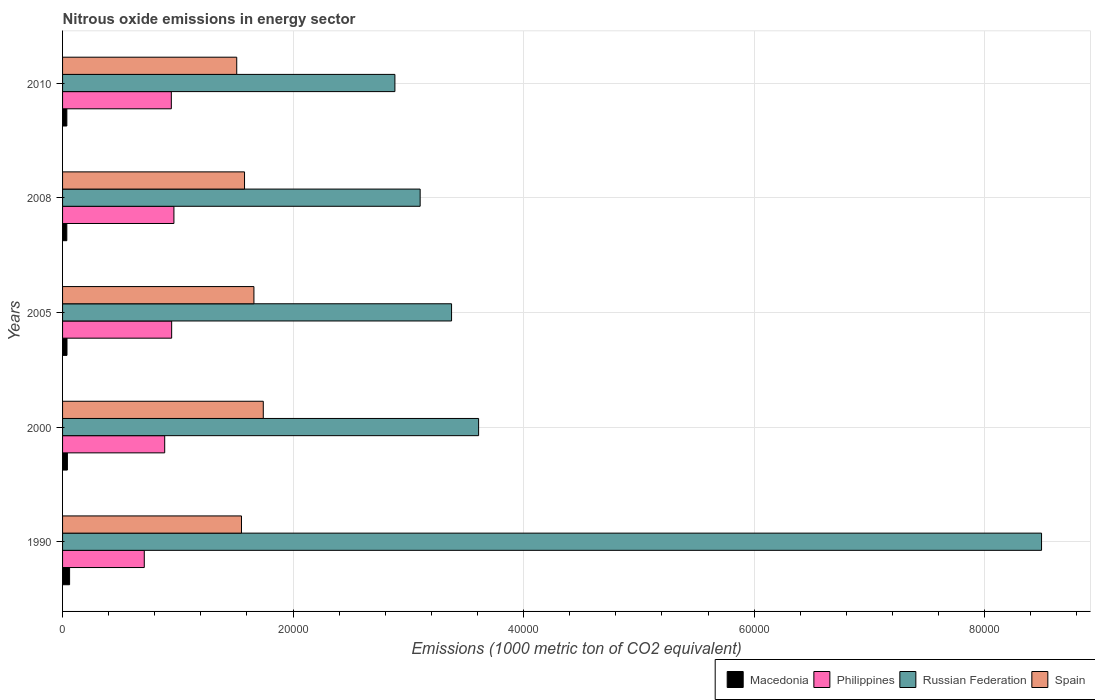Are the number of bars per tick equal to the number of legend labels?
Offer a terse response. Yes. Are the number of bars on each tick of the Y-axis equal?
Your answer should be compact. Yes. How many bars are there on the 4th tick from the bottom?
Your answer should be compact. 4. In how many cases, is the number of bars for a given year not equal to the number of legend labels?
Provide a short and direct response. 0. What is the amount of nitrous oxide emitted in Spain in 2000?
Ensure brevity in your answer.  1.74e+04. Across all years, what is the maximum amount of nitrous oxide emitted in Macedonia?
Give a very brief answer. 610.4. Across all years, what is the minimum amount of nitrous oxide emitted in Philippines?
Offer a terse response. 7090.2. What is the total amount of nitrous oxide emitted in Macedonia in the graph?
Provide a succinct answer. 2151.1. What is the difference between the amount of nitrous oxide emitted in Philippines in 2000 and that in 2008?
Provide a succinct answer. -799.7. What is the difference between the amount of nitrous oxide emitted in Russian Federation in 2000 and the amount of nitrous oxide emitted in Spain in 2008?
Ensure brevity in your answer.  2.03e+04. What is the average amount of nitrous oxide emitted in Philippines per year?
Give a very brief answer. 8902.72. In the year 1990, what is the difference between the amount of nitrous oxide emitted in Russian Federation and amount of nitrous oxide emitted in Spain?
Provide a short and direct response. 6.94e+04. In how many years, is the amount of nitrous oxide emitted in Macedonia greater than 20000 1000 metric ton?
Make the answer very short. 0. What is the ratio of the amount of nitrous oxide emitted in Spain in 2008 to that in 2010?
Ensure brevity in your answer.  1.04. Is the difference between the amount of nitrous oxide emitted in Russian Federation in 2005 and 2010 greater than the difference between the amount of nitrous oxide emitted in Spain in 2005 and 2010?
Keep it short and to the point. Yes. What is the difference between the highest and the second highest amount of nitrous oxide emitted in Philippines?
Your response must be concise. 195.7. What is the difference between the highest and the lowest amount of nitrous oxide emitted in Russian Federation?
Ensure brevity in your answer.  5.61e+04. Is the sum of the amount of nitrous oxide emitted in Macedonia in 2005 and 2008 greater than the maximum amount of nitrous oxide emitted in Philippines across all years?
Your response must be concise. No. What does the 1st bar from the top in 1990 represents?
Provide a succinct answer. Spain. What does the 4th bar from the bottom in 2008 represents?
Your answer should be compact. Spain. Is it the case that in every year, the sum of the amount of nitrous oxide emitted in Macedonia and amount of nitrous oxide emitted in Russian Federation is greater than the amount of nitrous oxide emitted in Spain?
Provide a succinct answer. Yes. How many years are there in the graph?
Your answer should be very brief. 5. What is the difference between two consecutive major ticks on the X-axis?
Provide a succinct answer. 2.00e+04. Are the values on the major ticks of X-axis written in scientific E-notation?
Give a very brief answer. No. Does the graph contain any zero values?
Provide a succinct answer. No. Does the graph contain grids?
Your response must be concise. Yes. How are the legend labels stacked?
Your response must be concise. Horizontal. What is the title of the graph?
Make the answer very short. Nitrous oxide emissions in energy sector. What is the label or title of the X-axis?
Your answer should be compact. Emissions (1000 metric ton of CO2 equivalent). What is the label or title of the Y-axis?
Provide a short and direct response. Years. What is the Emissions (1000 metric ton of CO2 equivalent) of Macedonia in 1990?
Keep it short and to the point. 610.4. What is the Emissions (1000 metric ton of CO2 equivalent) of Philippines in 1990?
Give a very brief answer. 7090.2. What is the Emissions (1000 metric ton of CO2 equivalent) of Russian Federation in 1990?
Provide a short and direct response. 8.49e+04. What is the Emissions (1000 metric ton of CO2 equivalent) of Spain in 1990?
Keep it short and to the point. 1.55e+04. What is the Emissions (1000 metric ton of CO2 equivalent) of Macedonia in 2000?
Give a very brief answer. 418.3. What is the Emissions (1000 metric ton of CO2 equivalent) in Philippines in 2000?
Your response must be concise. 8861.1. What is the Emissions (1000 metric ton of CO2 equivalent) of Russian Federation in 2000?
Your answer should be compact. 3.61e+04. What is the Emissions (1000 metric ton of CO2 equivalent) in Spain in 2000?
Provide a succinct answer. 1.74e+04. What is the Emissions (1000 metric ton of CO2 equivalent) of Macedonia in 2005?
Provide a short and direct response. 382.8. What is the Emissions (1000 metric ton of CO2 equivalent) in Philippines in 2005?
Ensure brevity in your answer.  9465.1. What is the Emissions (1000 metric ton of CO2 equivalent) in Russian Federation in 2005?
Your response must be concise. 3.37e+04. What is the Emissions (1000 metric ton of CO2 equivalent) of Spain in 2005?
Offer a very short reply. 1.66e+04. What is the Emissions (1000 metric ton of CO2 equivalent) of Macedonia in 2008?
Ensure brevity in your answer.  368. What is the Emissions (1000 metric ton of CO2 equivalent) of Philippines in 2008?
Offer a terse response. 9660.8. What is the Emissions (1000 metric ton of CO2 equivalent) of Russian Federation in 2008?
Offer a very short reply. 3.10e+04. What is the Emissions (1000 metric ton of CO2 equivalent) of Spain in 2008?
Your answer should be very brief. 1.58e+04. What is the Emissions (1000 metric ton of CO2 equivalent) in Macedonia in 2010?
Offer a terse response. 371.6. What is the Emissions (1000 metric ton of CO2 equivalent) in Philippines in 2010?
Ensure brevity in your answer.  9436.4. What is the Emissions (1000 metric ton of CO2 equivalent) in Russian Federation in 2010?
Your answer should be compact. 2.88e+04. What is the Emissions (1000 metric ton of CO2 equivalent) in Spain in 2010?
Offer a very short reply. 1.51e+04. Across all years, what is the maximum Emissions (1000 metric ton of CO2 equivalent) of Macedonia?
Keep it short and to the point. 610.4. Across all years, what is the maximum Emissions (1000 metric ton of CO2 equivalent) in Philippines?
Provide a short and direct response. 9660.8. Across all years, what is the maximum Emissions (1000 metric ton of CO2 equivalent) in Russian Federation?
Offer a very short reply. 8.49e+04. Across all years, what is the maximum Emissions (1000 metric ton of CO2 equivalent) in Spain?
Ensure brevity in your answer.  1.74e+04. Across all years, what is the minimum Emissions (1000 metric ton of CO2 equivalent) in Macedonia?
Give a very brief answer. 368. Across all years, what is the minimum Emissions (1000 metric ton of CO2 equivalent) in Philippines?
Provide a short and direct response. 7090.2. Across all years, what is the minimum Emissions (1000 metric ton of CO2 equivalent) in Russian Federation?
Give a very brief answer. 2.88e+04. Across all years, what is the minimum Emissions (1000 metric ton of CO2 equivalent) in Spain?
Your answer should be compact. 1.51e+04. What is the total Emissions (1000 metric ton of CO2 equivalent) in Macedonia in the graph?
Provide a succinct answer. 2151.1. What is the total Emissions (1000 metric ton of CO2 equivalent) of Philippines in the graph?
Your response must be concise. 4.45e+04. What is the total Emissions (1000 metric ton of CO2 equivalent) in Russian Federation in the graph?
Give a very brief answer. 2.15e+05. What is the total Emissions (1000 metric ton of CO2 equivalent) of Spain in the graph?
Ensure brevity in your answer.  8.04e+04. What is the difference between the Emissions (1000 metric ton of CO2 equivalent) of Macedonia in 1990 and that in 2000?
Your answer should be compact. 192.1. What is the difference between the Emissions (1000 metric ton of CO2 equivalent) of Philippines in 1990 and that in 2000?
Make the answer very short. -1770.9. What is the difference between the Emissions (1000 metric ton of CO2 equivalent) in Russian Federation in 1990 and that in 2000?
Keep it short and to the point. 4.88e+04. What is the difference between the Emissions (1000 metric ton of CO2 equivalent) of Spain in 1990 and that in 2000?
Your answer should be very brief. -1890.8. What is the difference between the Emissions (1000 metric ton of CO2 equivalent) of Macedonia in 1990 and that in 2005?
Ensure brevity in your answer.  227.6. What is the difference between the Emissions (1000 metric ton of CO2 equivalent) in Philippines in 1990 and that in 2005?
Make the answer very short. -2374.9. What is the difference between the Emissions (1000 metric ton of CO2 equivalent) in Russian Federation in 1990 and that in 2005?
Offer a terse response. 5.12e+04. What is the difference between the Emissions (1000 metric ton of CO2 equivalent) in Spain in 1990 and that in 2005?
Give a very brief answer. -1078.3. What is the difference between the Emissions (1000 metric ton of CO2 equivalent) of Macedonia in 1990 and that in 2008?
Make the answer very short. 242.4. What is the difference between the Emissions (1000 metric ton of CO2 equivalent) in Philippines in 1990 and that in 2008?
Ensure brevity in your answer.  -2570.6. What is the difference between the Emissions (1000 metric ton of CO2 equivalent) in Russian Federation in 1990 and that in 2008?
Offer a terse response. 5.39e+04. What is the difference between the Emissions (1000 metric ton of CO2 equivalent) in Spain in 1990 and that in 2008?
Ensure brevity in your answer.  -264.1. What is the difference between the Emissions (1000 metric ton of CO2 equivalent) in Macedonia in 1990 and that in 2010?
Make the answer very short. 238.8. What is the difference between the Emissions (1000 metric ton of CO2 equivalent) in Philippines in 1990 and that in 2010?
Your answer should be compact. -2346.2. What is the difference between the Emissions (1000 metric ton of CO2 equivalent) in Russian Federation in 1990 and that in 2010?
Keep it short and to the point. 5.61e+04. What is the difference between the Emissions (1000 metric ton of CO2 equivalent) in Spain in 1990 and that in 2010?
Your answer should be compact. 411.7. What is the difference between the Emissions (1000 metric ton of CO2 equivalent) of Macedonia in 2000 and that in 2005?
Your answer should be very brief. 35.5. What is the difference between the Emissions (1000 metric ton of CO2 equivalent) in Philippines in 2000 and that in 2005?
Provide a short and direct response. -604. What is the difference between the Emissions (1000 metric ton of CO2 equivalent) in Russian Federation in 2000 and that in 2005?
Offer a very short reply. 2347.2. What is the difference between the Emissions (1000 metric ton of CO2 equivalent) of Spain in 2000 and that in 2005?
Provide a short and direct response. 812.5. What is the difference between the Emissions (1000 metric ton of CO2 equivalent) in Macedonia in 2000 and that in 2008?
Provide a succinct answer. 50.3. What is the difference between the Emissions (1000 metric ton of CO2 equivalent) of Philippines in 2000 and that in 2008?
Provide a succinct answer. -799.7. What is the difference between the Emissions (1000 metric ton of CO2 equivalent) of Russian Federation in 2000 and that in 2008?
Offer a terse response. 5072.4. What is the difference between the Emissions (1000 metric ton of CO2 equivalent) in Spain in 2000 and that in 2008?
Offer a very short reply. 1626.7. What is the difference between the Emissions (1000 metric ton of CO2 equivalent) in Macedonia in 2000 and that in 2010?
Offer a terse response. 46.7. What is the difference between the Emissions (1000 metric ton of CO2 equivalent) of Philippines in 2000 and that in 2010?
Offer a terse response. -575.3. What is the difference between the Emissions (1000 metric ton of CO2 equivalent) in Russian Federation in 2000 and that in 2010?
Offer a very short reply. 7261.9. What is the difference between the Emissions (1000 metric ton of CO2 equivalent) of Spain in 2000 and that in 2010?
Your answer should be compact. 2302.5. What is the difference between the Emissions (1000 metric ton of CO2 equivalent) of Philippines in 2005 and that in 2008?
Offer a terse response. -195.7. What is the difference between the Emissions (1000 metric ton of CO2 equivalent) in Russian Federation in 2005 and that in 2008?
Your answer should be compact. 2725.2. What is the difference between the Emissions (1000 metric ton of CO2 equivalent) in Spain in 2005 and that in 2008?
Keep it short and to the point. 814.2. What is the difference between the Emissions (1000 metric ton of CO2 equivalent) in Philippines in 2005 and that in 2010?
Your answer should be very brief. 28.7. What is the difference between the Emissions (1000 metric ton of CO2 equivalent) of Russian Federation in 2005 and that in 2010?
Offer a very short reply. 4914.7. What is the difference between the Emissions (1000 metric ton of CO2 equivalent) in Spain in 2005 and that in 2010?
Your answer should be compact. 1490. What is the difference between the Emissions (1000 metric ton of CO2 equivalent) of Philippines in 2008 and that in 2010?
Give a very brief answer. 224.4. What is the difference between the Emissions (1000 metric ton of CO2 equivalent) in Russian Federation in 2008 and that in 2010?
Your answer should be very brief. 2189.5. What is the difference between the Emissions (1000 metric ton of CO2 equivalent) in Spain in 2008 and that in 2010?
Provide a short and direct response. 675.8. What is the difference between the Emissions (1000 metric ton of CO2 equivalent) of Macedonia in 1990 and the Emissions (1000 metric ton of CO2 equivalent) of Philippines in 2000?
Provide a short and direct response. -8250.7. What is the difference between the Emissions (1000 metric ton of CO2 equivalent) of Macedonia in 1990 and the Emissions (1000 metric ton of CO2 equivalent) of Russian Federation in 2000?
Your answer should be very brief. -3.55e+04. What is the difference between the Emissions (1000 metric ton of CO2 equivalent) of Macedonia in 1990 and the Emissions (1000 metric ton of CO2 equivalent) of Spain in 2000?
Give a very brief answer. -1.68e+04. What is the difference between the Emissions (1000 metric ton of CO2 equivalent) of Philippines in 1990 and the Emissions (1000 metric ton of CO2 equivalent) of Russian Federation in 2000?
Offer a very short reply. -2.90e+04. What is the difference between the Emissions (1000 metric ton of CO2 equivalent) in Philippines in 1990 and the Emissions (1000 metric ton of CO2 equivalent) in Spain in 2000?
Your response must be concise. -1.03e+04. What is the difference between the Emissions (1000 metric ton of CO2 equivalent) of Russian Federation in 1990 and the Emissions (1000 metric ton of CO2 equivalent) of Spain in 2000?
Your answer should be very brief. 6.75e+04. What is the difference between the Emissions (1000 metric ton of CO2 equivalent) of Macedonia in 1990 and the Emissions (1000 metric ton of CO2 equivalent) of Philippines in 2005?
Keep it short and to the point. -8854.7. What is the difference between the Emissions (1000 metric ton of CO2 equivalent) in Macedonia in 1990 and the Emissions (1000 metric ton of CO2 equivalent) in Russian Federation in 2005?
Give a very brief answer. -3.31e+04. What is the difference between the Emissions (1000 metric ton of CO2 equivalent) of Macedonia in 1990 and the Emissions (1000 metric ton of CO2 equivalent) of Spain in 2005?
Your answer should be compact. -1.60e+04. What is the difference between the Emissions (1000 metric ton of CO2 equivalent) of Philippines in 1990 and the Emissions (1000 metric ton of CO2 equivalent) of Russian Federation in 2005?
Your response must be concise. -2.67e+04. What is the difference between the Emissions (1000 metric ton of CO2 equivalent) in Philippines in 1990 and the Emissions (1000 metric ton of CO2 equivalent) in Spain in 2005?
Provide a short and direct response. -9511.1. What is the difference between the Emissions (1000 metric ton of CO2 equivalent) in Russian Federation in 1990 and the Emissions (1000 metric ton of CO2 equivalent) in Spain in 2005?
Your answer should be compact. 6.83e+04. What is the difference between the Emissions (1000 metric ton of CO2 equivalent) in Macedonia in 1990 and the Emissions (1000 metric ton of CO2 equivalent) in Philippines in 2008?
Provide a short and direct response. -9050.4. What is the difference between the Emissions (1000 metric ton of CO2 equivalent) in Macedonia in 1990 and the Emissions (1000 metric ton of CO2 equivalent) in Russian Federation in 2008?
Give a very brief answer. -3.04e+04. What is the difference between the Emissions (1000 metric ton of CO2 equivalent) in Macedonia in 1990 and the Emissions (1000 metric ton of CO2 equivalent) in Spain in 2008?
Your answer should be compact. -1.52e+04. What is the difference between the Emissions (1000 metric ton of CO2 equivalent) in Philippines in 1990 and the Emissions (1000 metric ton of CO2 equivalent) in Russian Federation in 2008?
Provide a short and direct response. -2.39e+04. What is the difference between the Emissions (1000 metric ton of CO2 equivalent) of Philippines in 1990 and the Emissions (1000 metric ton of CO2 equivalent) of Spain in 2008?
Your answer should be compact. -8696.9. What is the difference between the Emissions (1000 metric ton of CO2 equivalent) in Russian Federation in 1990 and the Emissions (1000 metric ton of CO2 equivalent) in Spain in 2008?
Offer a very short reply. 6.91e+04. What is the difference between the Emissions (1000 metric ton of CO2 equivalent) in Macedonia in 1990 and the Emissions (1000 metric ton of CO2 equivalent) in Philippines in 2010?
Give a very brief answer. -8826. What is the difference between the Emissions (1000 metric ton of CO2 equivalent) in Macedonia in 1990 and the Emissions (1000 metric ton of CO2 equivalent) in Russian Federation in 2010?
Provide a succinct answer. -2.82e+04. What is the difference between the Emissions (1000 metric ton of CO2 equivalent) of Macedonia in 1990 and the Emissions (1000 metric ton of CO2 equivalent) of Spain in 2010?
Offer a terse response. -1.45e+04. What is the difference between the Emissions (1000 metric ton of CO2 equivalent) of Philippines in 1990 and the Emissions (1000 metric ton of CO2 equivalent) of Russian Federation in 2010?
Offer a very short reply. -2.17e+04. What is the difference between the Emissions (1000 metric ton of CO2 equivalent) in Philippines in 1990 and the Emissions (1000 metric ton of CO2 equivalent) in Spain in 2010?
Ensure brevity in your answer.  -8021.1. What is the difference between the Emissions (1000 metric ton of CO2 equivalent) in Russian Federation in 1990 and the Emissions (1000 metric ton of CO2 equivalent) in Spain in 2010?
Provide a succinct answer. 6.98e+04. What is the difference between the Emissions (1000 metric ton of CO2 equivalent) in Macedonia in 2000 and the Emissions (1000 metric ton of CO2 equivalent) in Philippines in 2005?
Offer a very short reply. -9046.8. What is the difference between the Emissions (1000 metric ton of CO2 equivalent) in Macedonia in 2000 and the Emissions (1000 metric ton of CO2 equivalent) in Russian Federation in 2005?
Provide a short and direct response. -3.33e+04. What is the difference between the Emissions (1000 metric ton of CO2 equivalent) of Macedonia in 2000 and the Emissions (1000 metric ton of CO2 equivalent) of Spain in 2005?
Your response must be concise. -1.62e+04. What is the difference between the Emissions (1000 metric ton of CO2 equivalent) of Philippines in 2000 and the Emissions (1000 metric ton of CO2 equivalent) of Russian Federation in 2005?
Your answer should be very brief. -2.49e+04. What is the difference between the Emissions (1000 metric ton of CO2 equivalent) of Philippines in 2000 and the Emissions (1000 metric ton of CO2 equivalent) of Spain in 2005?
Offer a terse response. -7740.2. What is the difference between the Emissions (1000 metric ton of CO2 equivalent) in Russian Federation in 2000 and the Emissions (1000 metric ton of CO2 equivalent) in Spain in 2005?
Your answer should be very brief. 1.95e+04. What is the difference between the Emissions (1000 metric ton of CO2 equivalent) of Macedonia in 2000 and the Emissions (1000 metric ton of CO2 equivalent) of Philippines in 2008?
Your answer should be very brief. -9242.5. What is the difference between the Emissions (1000 metric ton of CO2 equivalent) in Macedonia in 2000 and the Emissions (1000 metric ton of CO2 equivalent) in Russian Federation in 2008?
Your response must be concise. -3.06e+04. What is the difference between the Emissions (1000 metric ton of CO2 equivalent) of Macedonia in 2000 and the Emissions (1000 metric ton of CO2 equivalent) of Spain in 2008?
Your response must be concise. -1.54e+04. What is the difference between the Emissions (1000 metric ton of CO2 equivalent) of Philippines in 2000 and the Emissions (1000 metric ton of CO2 equivalent) of Russian Federation in 2008?
Keep it short and to the point. -2.22e+04. What is the difference between the Emissions (1000 metric ton of CO2 equivalent) of Philippines in 2000 and the Emissions (1000 metric ton of CO2 equivalent) of Spain in 2008?
Ensure brevity in your answer.  -6926. What is the difference between the Emissions (1000 metric ton of CO2 equivalent) in Russian Federation in 2000 and the Emissions (1000 metric ton of CO2 equivalent) in Spain in 2008?
Offer a terse response. 2.03e+04. What is the difference between the Emissions (1000 metric ton of CO2 equivalent) of Macedonia in 2000 and the Emissions (1000 metric ton of CO2 equivalent) of Philippines in 2010?
Give a very brief answer. -9018.1. What is the difference between the Emissions (1000 metric ton of CO2 equivalent) in Macedonia in 2000 and the Emissions (1000 metric ton of CO2 equivalent) in Russian Federation in 2010?
Ensure brevity in your answer.  -2.84e+04. What is the difference between the Emissions (1000 metric ton of CO2 equivalent) of Macedonia in 2000 and the Emissions (1000 metric ton of CO2 equivalent) of Spain in 2010?
Give a very brief answer. -1.47e+04. What is the difference between the Emissions (1000 metric ton of CO2 equivalent) in Philippines in 2000 and the Emissions (1000 metric ton of CO2 equivalent) in Russian Federation in 2010?
Ensure brevity in your answer.  -2.00e+04. What is the difference between the Emissions (1000 metric ton of CO2 equivalent) of Philippines in 2000 and the Emissions (1000 metric ton of CO2 equivalent) of Spain in 2010?
Give a very brief answer. -6250.2. What is the difference between the Emissions (1000 metric ton of CO2 equivalent) in Russian Federation in 2000 and the Emissions (1000 metric ton of CO2 equivalent) in Spain in 2010?
Your answer should be compact. 2.10e+04. What is the difference between the Emissions (1000 metric ton of CO2 equivalent) in Macedonia in 2005 and the Emissions (1000 metric ton of CO2 equivalent) in Philippines in 2008?
Your answer should be compact. -9278. What is the difference between the Emissions (1000 metric ton of CO2 equivalent) of Macedonia in 2005 and the Emissions (1000 metric ton of CO2 equivalent) of Russian Federation in 2008?
Provide a short and direct response. -3.06e+04. What is the difference between the Emissions (1000 metric ton of CO2 equivalent) of Macedonia in 2005 and the Emissions (1000 metric ton of CO2 equivalent) of Spain in 2008?
Provide a short and direct response. -1.54e+04. What is the difference between the Emissions (1000 metric ton of CO2 equivalent) in Philippines in 2005 and the Emissions (1000 metric ton of CO2 equivalent) in Russian Federation in 2008?
Your response must be concise. -2.16e+04. What is the difference between the Emissions (1000 metric ton of CO2 equivalent) in Philippines in 2005 and the Emissions (1000 metric ton of CO2 equivalent) in Spain in 2008?
Provide a short and direct response. -6322. What is the difference between the Emissions (1000 metric ton of CO2 equivalent) of Russian Federation in 2005 and the Emissions (1000 metric ton of CO2 equivalent) of Spain in 2008?
Your response must be concise. 1.80e+04. What is the difference between the Emissions (1000 metric ton of CO2 equivalent) in Macedonia in 2005 and the Emissions (1000 metric ton of CO2 equivalent) in Philippines in 2010?
Give a very brief answer. -9053.6. What is the difference between the Emissions (1000 metric ton of CO2 equivalent) of Macedonia in 2005 and the Emissions (1000 metric ton of CO2 equivalent) of Russian Federation in 2010?
Offer a terse response. -2.85e+04. What is the difference between the Emissions (1000 metric ton of CO2 equivalent) of Macedonia in 2005 and the Emissions (1000 metric ton of CO2 equivalent) of Spain in 2010?
Keep it short and to the point. -1.47e+04. What is the difference between the Emissions (1000 metric ton of CO2 equivalent) in Philippines in 2005 and the Emissions (1000 metric ton of CO2 equivalent) in Russian Federation in 2010?
Your answer should be very brief. -1.94e+04. What is the difference between the Emissions (1000 metric ton of CO2 equivalent) of Philippines in 2005 and the Emissions (1000 metric ton of CO2 equivalent) of Spain in 2010?
Your answer should be compact. -5646.2. What is the difference between the Emissions (1000 metric ton of CO2 equivalent) of Russian Federation in 2005 and the Emissions (1000 metric ton of CO2 equivalent) of Spain in 2010?
Offer a very short reply. 1.86e+04. What is the difference between the Emissions (1000 metric ton of CO2 equivalent) of Macedonia in 2008 and the Emissions (1000 metric ton of CO2 equivalent) of Philippines in 2010?
Make the answer very short. -9068.4. What is the difference between the Emissions (1000 metric ton of CO2 equivalent) in Macedonia in 2008 and the Emissions (1000 metric ton of CO2 equivalent) in Russian Federation in 2010?
Make the answer very short. -2.85e+04. What is the difference between the Emissions (1000 metric ton of CO2 equivalent) in Macedonia in 2008 and the Emissions (1000 metric ton of CO2 equivalent) in Spain in 2010?
Offer a terse response. -1.47e+04. What is the difference between the Emissions (1000 metric ton of CO2 equivalent) in Philippines in 2008 and the Emissions (1000 metric ton of CO2 equivalent) in Russian Federation in 2010?
Keep it short and to the point. -1.92e+04. What is the difference between the Emissions (1000 metric ton of CO2 equivalent) in Philippines in 2008 and the Emissions (1000 metric ton of CO2 equivalent) in Spain in 2010?
Ensure brevity in your answer.  -5450.5. What is the difference between the Emissions (1000 metric ton of CO2 equivalent) in Russian Federation in 2008 and the Emissions (1000 metric ton of CO2 equivalent) in Spain in 2010?
Offer a very short reply. 1.59e+04. What is the average Emissions (1000 metric ton of CO2 equivalent) of Macedonia per year?
Make the answer very short. 430.22. What is the average Emissions (1000 metric ton of CO2 equivalent) in Philippines per year?
Keep it short and to the point. 8902.72. What is the average Emissions (1000 metric ton of CO2 equivalent) in Russian Federation per year?
Your answer should be compact. 4.29e+04. What is the average Emissions (1000 metric ton of CO2 equivalent) of Spain per year?
Give a very brief answer. 1.61e+04. In the year 1990, what is the difference between the Emissions (1000 metric ton of CO2 equivalent) of Macedonia and Emissions (1000 metric ton of CO2 equivalent) of Philippines?
Offer a very short reply. -6479.8. In the year 1990, what is the difference between the Emissions (1000 metric ton of CO2 equivalent) of Macedonia and Emissions (1000 metric ton of CO2 equivalent) of Russian Federation?
Offer a terse response. -8.43e+04. In the year 1990, what is the difference between the Emissions (1000 metric ton of CO2 equivalent) of Macedonia and Emissions (1000 metric ton of CO2 equivalent) of Spain?
Your answer should be very brief. -1.49e+04. In the year 1990, what is the difference between the Emissions (1000 metric ton of CO2 equivalent) in Philippines and Emissions (1000 metric ton of CO2 equivalent) in Russian Federation?
Give a very brief answer. -7.78e+04. In the year 1990, what is the difference between the Emissions (1000 metric ton of CO2 equivalent) of Philippines and Emissions (1000 metric ton of CO2 equivalent) of Spain?
Keep it short and to the point. -8432.8. In the year 1990, what is the difference between the Emissions (1000 metric ton of CO2 equivalent) in Russian Federation and Emissions (1000 metric ton of CO2 equivalent) in Spain?
Your response must be concise. 6.94e+04. In the year 2000, what is the difference between the Emissions (1000 metric ton of CO2 equivalent) of Macedonia and Emissions (1000 metric ton of CO2 equivalent) of Philippines?
Offer a very short reply. -8442.8. In the year 2000, what is the difference between the Emissions (1000 metric ton of CO2 equivalent) of Macedonia and Emissions (1000 metric ton of CO2 equivalent) of Russian Federation?
Offer a very short reply. -3.57e+04. In the year 2000, what is the difference between the Emissions (1000 metric ton of CO2 equivalent) of Macedonia and Emissions (1000 metric ton of CO2 equivalent) of Spain?
Offer a very short reply. -1.70e+04. In the year 2000, what is the difference between the Emissions (1000 metric ton of CO2 equivalent) of Philippines and Emissions (1000 metric ton of CO2 equivalent) of Russian Federation?
Your answer should be very brief. -2.72e+04. In the year 2000, what is the difference between the Emissions (1000 metric ton of CO2 equivalent) in Philippines and Emissions (1000 metric ton of CO2 equivalent) in Spain?
Ensure brevity in your answer.  -8552.7. In the year 2000, what is the difference between the Emissions (1000 metric ton of CO2 equivalent) of Russian Federation and Emissions (1000 metric ton of CO2 equivalent) of Spain?
Provide a succinct answer. 1.87e+04. In the year 2005, what is the difference between the Emissions (1000 metric ton of CO2 equivalent) of Macedonia and Emissions (1000 metric ton of CO2 equivalent) of Philippines?
Give a very brief answer. -9082.3. In the year 2005, what is the difference between the Emissions (1000 metric ton of CO2 equivalent) in Macedonia and Emissions (1000 metric ton of CO2 equivalent) in Russian Federation?
Keep it short and to the point. -3.34e+04. In the year 2005, what is the difference between the Emissions (1000 metric ton of CO2 equivalent) in Macedonia and Emissions (1000 metric ton of CO2 equivalent) in Spain?
Provide a succinct answer. -1.62e+04. In the year 2005, what is the difference between the Emissions (1000 metric ton of CO2 equivalent) of Philippines and Emissions (1000 metric ton of CO2 equivalent) of Russian Federation?
Provide a short and direct response. -2.43e+04. In the year 2005, what is the difference between the Emissions (1000 metric ton of CO2 equivalent) in Philippines and Emissions (1000 metric ton of CO2 equivalent) in Spain?
Ensure brevity in your answer.  -7136.2. In the year 2005, what is the difference between the Emissions (1000 metric ton of CO2 equivalent) in Russian Federation and Emissions (1000 metric ton of CO2 equivalent) in Spain?
Your response must be concise. 1.71e+04. In the year 2008, what is the difference between the Emissions (1000 metric ton of CO2 equivalent) in Macedonia and Emissions (1000 metric ton of CO2 equivalent) in Philippines?
Ensure brevity in your answer.  -9292.8. In the year 2008, what is the difference between the Emissions (1000 metric ton of CO2 equivalent) in Macedonia and Emissions (1000 metric ton of CO2 equivalent) in Russian Federation?
Offer a very short reply. -3.07e+04. In the year 2008, what is the difference between the Emissions (1000 metric ton of CO2 equivalent) of Macedonia and Emissions (1000 metric ton of CO2 equivalent) of Spain?
Your answer should be very brief. -1.54e+04. In the year 2008, what is the difference between the Emissions (1000 metric ton of CO2 equivalent) in Philippines and Emissions (1000 metric ton of CO2 equivalent) in Russian Federation?
Offer a terse response. -2.14e+04. In the year 2008, what is the difference between the Emissions (1000 metric ton of CO2 equivalent) in Philippines and Emissions (1000 metric ton of CO2 equivalent) in Spain?
Your answer should be very brief. -6126.3. In the year 2008, what is the difference between the Emissions (1000 metric ton of CO2 equivalent) of Russian Federation and Emissions (1000 metric ton of CO2 equivalent) of Spain?
Give a very brief answer. 1.52e+04. In the year 2010, what is the difference between the Emissions (1000 metric ton of CO2 equivalent) in Macedonia and Emissions (1000 metric ton of CO2 equivalent) in Philippines?
Your answer should be compact. -9064.8. In the year 2010, what is the difference between the Emissions (1000 metric ton of CO2 equivalent) of Macedonia and Emissions (1000 metric ton of CO2 equivalent) of Russian Federation?
Ensure brevity in your answer.  -2.85e+04. In the year 2010, what is the difference between the Emissions (1000 metric ton of CO2 equivalent) in Macedonia and Emissions (1000 metric ton of CO2 equivalent) in Spain?
Give a very brief answer. -1.47e+04. In the year 2010, what is the difference between the Emissions (1000 metric ton of CO2 equivalent) in Philippines and Emissions (1000 metric ton of CO2 equivalent) in Russian Federation?
Offer a terse response. -1.94e+04. In the year 2010, what is the difference between the Emissions (1000 metric ton of CO2 equivalent) in Philippines and Emissions (1000 metric ton of CO2 equivalent) in Spain?
Your answer should be compact. -5674.9. In the year 2010, what is the difference between the Emissions (1000 metric ton of CO2 equivalent) in Russian Federation and Emissions (1000 metric ton of CO2 equivalent) in Spain?
Offer a terse response. 1.37e+04. What is the ratio of the Emissions (1000 metric ton of CO2 equivalent) of Macedonia in 1990 to that in 2000?
Provide a succinct answer. 1.46. What is the ratio of the Emissions (1000 metric ton of CO2 equivalent) of Philippines in 1990 to that in 2000?
Your response must be concise. 0.8. What is the ratio of the Emissions (1000 metric ton of CO2 equivalent) in Russian Federation in 1990 to that in 2000?
Make the answer very short. 2.35. What is the ratio of the Emissions (1000 metric ton of CO2 equivalent) of Spain in 1990 to that in 2000?
Your answer should be compact. 0.89. What is the ratio of the Emissions (1000 metric ton of CO2 equivalent) in Macedonia in 1990 to that in 2005?
Your answer should be compact. 1.59. What is the ratio of the Emissions (1000 metric ton of CO2 equivalent) of Philippines in 1990 to that in 2005?
Ensure brevity in your answer.  0.75. What is the ratio of the Emissions (1000 metric ton of CO2 equivalent) of Russian Federation in 1990 to that in 2005?
Your response must be concise. 2.52. What is the ratio of the Emissions (1000 metric ton of CO2 equivalent) in Spain in 1990 to that in 2005?
Offer a very short reply. 0.94. What is the ratio of the Emissions (1000 metric ton of CO2 equivalent) in Macedonia in 1990 to that in 2008?
Offer a terse response. 1.66. What is the ratio of the Emissions (1000 metric ton of CO2 equivalent) of Philippines in 1990 to that in 2008?
Offer a terse response. 0.73. What is the ratio of the Emissions (1000 metric ton of CO2 equivalent) in Russian Federation in 1990 to that in 2008?
Keep it short and to the point. 2.74. What is the ratio of the Emissions (1000 metric ton of CO2 equivalent) in Spain in 1990 to that in 2008?
Your answer should be compact. 0.98. What is the ratio of the Emissions (1000 metric ton of CO2 equivalent) of Macedonia in 1990 to that in 2010?
Your answer should be compact. 1.64. What is the ratio of the Emissions (1000 metric ton of CO2 equivalent) in Philippines in 1990 to that in 2010?
Offer a terse response. 0.75. What is the ratio of the Emissions (1000 metric ton of CO2 equivalent) of Russian Federation in 1990 to that in 2010?
Provide a short and direct response. 2.95. What is the ratio of the Emissions (1000 metric ton of CO2 equivalent) in Spain in 1990 to that in 2010?
Provide a short and direct response. 1.03. What is the ratio of the Emissions (1000 metric ton of CO2 equivalent) of Macedonia in 2000 to that in 2005?
Give a very brief answer. 1.09. What is the ratio of the Emissions (1000 metric ton of CO2 equivalent) in Philippines in 2000 to that in 2005?
Offer a very short reply. 0.94. What is the ratio of the Emissions (1000 metric ton of CO2 equivalent) of Russian Federation in 2000 to that in 2005?
Your response must be concise. 1.07. What is the ratio of the Emissions (1000 metric ton of CO2 equivalent) of Spain in 2000 to that in 2005?
Give a very brief answer. 1.05. What is the ratio of the Emissions (1000 metric ton of CO2 equivalent) of Macedonia in 2000 to that in 2008?
Your response must be concise. 1.14. What is the ratio of the Emissions (1000 metric ton of CO2 equivalent) of Philippines in 2000 to that in 2008?
Offer a terse response. 0.92. What is the ratio of the Emissions (1000 metric ton of CO2 equivalent) of Russian Federation in 2000 to that in 2008?
Provide a succinct answer. 1.16. What is the ratio of the Emissions (1000 metric ton of CO2 equivalent) of Spain in 2000 to that in 2008?
Offer a terse response. 1.1. What is the ratio of the Emissions (1000 metric ton of CO2 equivalent) in Macedonia in 2000 to that in 2010?
Offer a terse response. 1.13. What is the ratio of the Emissions (1000 metric ton of CO2 equivalent) of Philippines in 2000 to that in 2010?
Keep it short and to the point. 0.94. What is the ratio of the Emissions (1000 metric ton of CO2 equivalent) in Russian Federation in 2000 to that in 2010?
Your answer should be compact. 1.25. What is the ratio of the Emissions (1000 metric ton of CO2 equivalent) of Spain in 2000 to that in 2010?
Provide a succinct answer. 1.15. What is the ratio of the Emissions (1000 metric ton of CO2 equivalent) of Macedonia in 2005 to that in 2008?
Give a very brief answer. 1.04. What is the ratio of the Emissions (1000 metric ton of CO2 equivalent) in Philippines in 2005 to that in 2008?
Your response must be concise. 0.98. What is the ratio of the Emissions (1000 metric ton of CO2 equivalent) in Russian Federation in 2005 to that in 2008?
Offer a very short reply. 1.09. What is the ratio of the Emissions (1000 metric ton of CO2 equivalent) of Spain in 2005 to that in 2008?
Provide a succinct answer. 1.05. What is the ratio of the Emissions (1000 metric ton of CO2 equivalent) in Macedonia in 2005 to that in 2010?
Offer a very short reply. 1.03. What is the ratio of the Emissions (1000 metric ton of CO2 equivalent) of Russian Federation in 2005 to that in 2010?
Provide a succinct answer. 1.17. What is the ratio of the Emissions (1000 metric ton of CO2 equivalent) of Spain in 2005 to that in 2010?
Offer a terse response. 1.1. What is the ratio of the Emissions (1000 metric ton of CO2 equivalent) of Macedonia in 2008 to that in 2010?
Make the answer very short. 0.99. What is the ratio of the Emissions (1000 metric ton of CO2 equivalent) of Philippines in 2008 to that in 2010?
Provide a short and direct response. 1.02. What is the ratio of the Emissions (1000 metric ton of CO2 equivalent) in Russian Federation in 2008 to that in 2010?
Make the answer very short. 1.08. What is the ratio of the Emissions (1000 metric ton of CO2 equivalent) of Spain in 2008 to that in 2010?
Your answer should be very brief. 1.04. What is the difference between the highest and the second highest Emissions (1000 metric ton of CO2 equivalent) of Macedonia?
Provide a short and direct response. 192.1. What is the difference between the highest and the second highest Emissions (1000 metric ton of CO2 equivalent) of Philippines?
Offer a terse response. 195.7. What is the difference between the highest and the second highest Emissions (1000 metric ton of CO2 equivalent) of Russian Federation?
Provide a succinct answer. 4.88e+04. What is the difference between the highest and the second highest Emissions (1000 metric ton of CO2 equivalent) of Spain?
Provide a succinct answer. 812.5. What is the difference between the highest and the lowest Emissions (1000 metric ton of CO2 equivalent) of Macedonia?
Provide a succinct answer. 242.4. What is the difference between the highest and the lowest Emissions (1000 metric ton of CO2 equivalent) of Philippines?
Provide a succinct answer. 2570.6. What is the difference between the highest and the lowest Emissions (1000 metric ton of CO2 equivalent) of Russian Federation?
Make the answer very short. 5.61e+04. What is the difference between the highest and the lowest Emissions (1000 metric ton of CO2 equivalent) in Spain?
Provide a short and direct response. 2302.5. 